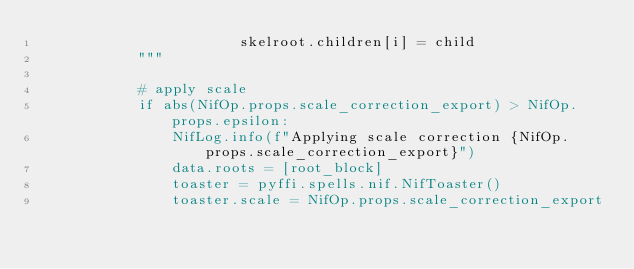Convert code to text. <code><loc_0><loc_0><loc_500><loc_500><_Python_>                        skelroot.children[i] = child
            """

            # apply scale
            if abs(NifOp.props.scale_correction_export) > NifOp.props.epsilon:
                NifLog.info(f"Applying scale correction {NifOp.props.scale_correction_export}")
                data.roots = [root_block]
                toaster = pyffi.spells.nif.NifToaster()
                toaster.scale = NifOp.props.scale_correction_export</code> 